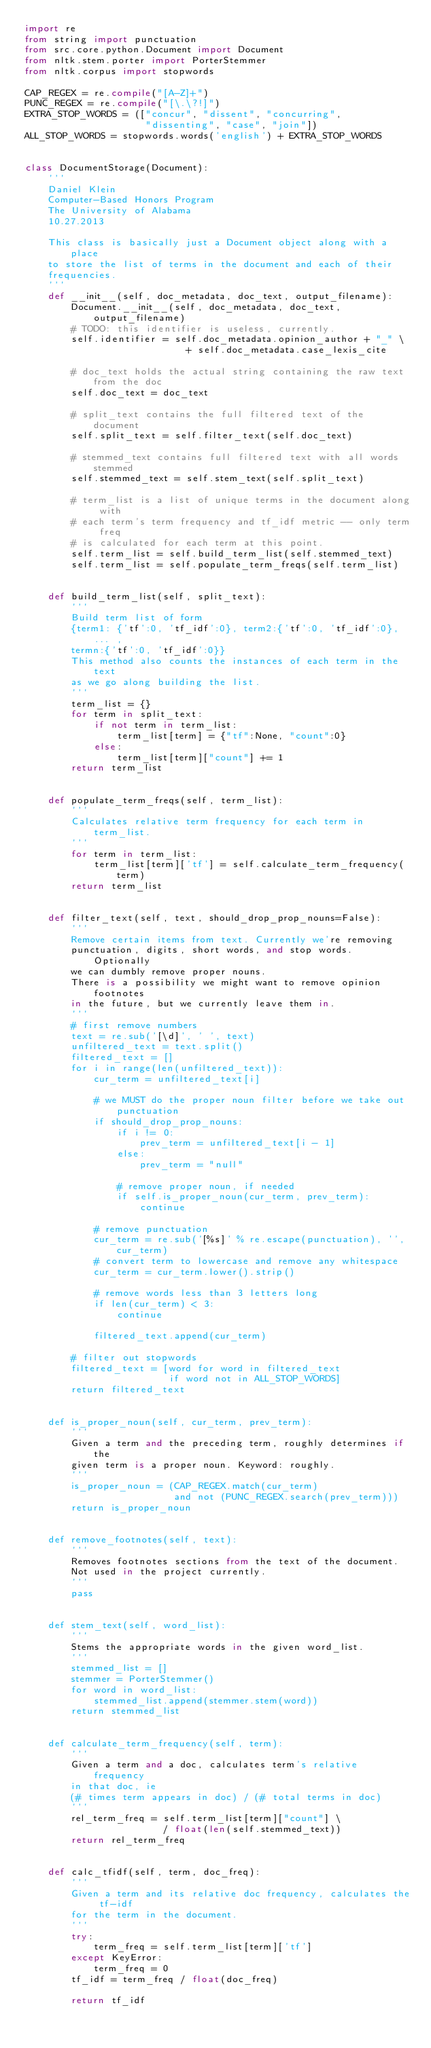<code> <loc_0><loc_0><loc_500><loc_500><_Python_>import re
from string import punctuation
from src.core.python.Document import Document
from nltk.stem.porter import PorterStemmer
from nltk.corpus import stopwords

CAP_REGEX = re.compile("[A-Z]+")
PUNC_REGEX = re.compile("[\.\?!]")
EXTRA_STOP_WORDS = (["concur", "dissent", "concurring", 
                     "dissenting", "case", "join"])
ALL_STOP_WORDS = stopwords.words('english') + EXTRA_STOP_WORDS


class DocumentStorage(Document):
    '''
    Daniel Klein
    Computer-Based Honors Program
    The University of Alabama
    10.27.2013
    
    This class is basically just a Document object along with a place
    to store the list of terms in the document and each of their 
    frequencies.
    '''
    def __init__(self, doc_metadata, doc_text, output_filename):        
        Document.__init__(self, doc_metadata, doc_text, output_filename)
        # TODO: this identifier is useless, currently.
        self.identifier = self.doc_metadata.opinion_author + "_" \
                            + self.doc_metadata.case_lexis_cite
                            
        # doc_text holds the actual string containing the raw text from the doc
        self.doc_text = doc_text

        # split_text contains the full filtered text of the document
        self.split_text = self.filter_text(self.doc_text)
        
        # stemmed_text contains full filtered text with all words stemmed
        self.stemmed_text = self.stem_text(self.split_text)
        
        # term_list is a list of unique terms in the document along with
        # each term's term frequency and tf_idf metric -- only term freq
        # is calculated for each term at this point.
        self.term_list = self.build_term_list(self.stemmed_text)
        self.term_list = self.populate_term_freqs(self.term_list)
        
        
    def build_term_list(self, split_text):
        '''
        Build term list of form 
        {term1: {'tf':0, 'tf_idf':0}, term2:{'tf':0, 'tf_idf':0}, ... , 
        termn:{'tf':0, 'tf_idf':0}}
        This method also counts the instances of each term in the text
        as we go along building the list.
        '''
        term_list = {}
        for term in split_text:
            if not term in term_list:
                term_list[term] = {"tf":None, "count":0}
            else:
                term_list[term]["count"] += 1            
        return term_list
    
    
    def populate_term_freqs(self, term_list):
        '''
        Calculates relative term frequency for each term in term_list.
        '''
        for term in term_list:
            term_list[term]['tf'] = self.calculate_term_frequency(term)
        return term_list
    
    
    def filter_text(self, text, should_drop_prop_nouns=False):
        '''
        Remove certain items from text. Currently we're removing
        punctuation, digits, short words, and stop words. Optionally 
        we can dumbly remove proper nouns. 
        There is a possibility we might want to remove opinion footnotes
        in the future, but we currently leave them in.
        '''
        # first remove numbers
        text = re.sub('[\d]', ' ', text)
        unfiltered_text = text.split()
        filtered_text = []
        for i in range(len(unfiltered_text)):
            cur_term = unfiltered_text[i]   
            
            # we MUST do the proper noun filter before we take out punctuation
            if should_drop_prop_nouns:
                if i != 0:
                    prev_term = unfiltered_text[i - 1]
                else:
                    prev_term = "null"

                # remove proper noun, if needed
                if self.is_proper_noun(cur_term, prev_term):
                    continue
            
            # remove punctuation
            cur_term = re.sub('[%s]' % re.escape(punctuation), '', cur_term)
            # convert term to lowercase and remove any whitespace  
            cur_term = cur_term.lower().strip()
            
            # remove words less than 3 letters long
            if len(cur_term) < 3:
                continue
          
            filtered_text.append(cur_term)
            
        # filter out stopwords
        filtered_text = [word for word in filtered_text 
                         if word not in ALL_STOP_WORDS] 
        return filtered_text
        
        
    def is_proper_noun(self, cur_term, prev_term):
        '''
        Given a term and the preceding term, roughly determines if the 
        given term is a proper noun. Keyword: roughly.
        '''
        is_proper_noun = (CAP_REGEX.match(cur_term)
                          and not (PUNC_REGEX.search(prev_term)))
        return is_proper_noun
        
    
    def remove_footnotes(self, text):
        '''
        Removes footnotes sections from the text of the document.
        Not used in the project currently.
        '''
        pass
    
    
    def stem_text(self, word_list):
        '''
        Stems the appropriate words in the given word_list.
        '''
        stemmed_list = []
        stemmer = PorterStemmer()
        for word in word_list:
            stemmed_list.append(stemmer.stem(word))
        return stemmed_list
    
    
    def calculate_term_frequency(self, term):
        '''
        Given a term and a doc, calculates term's relative frequency
        in that doc, ie
        (# times term appears in doc) / (# total terms in doc)
        '''
        rel_term_freq = self.term_list[term]["count"] \
                        / float(len(self.stemmed_text))
        return rel_term_freq
    
    
    def calc_tfidf(self, term, doc_freq):
        '''
        Given a term and its relative doc frequency, calculates the tf-idf 
        for the term in the document.
        '''
        try:
            term_freq = self.term_list[term]['tf']
        except KeyError:
            term_freq = 0
        tf_idf = term_freq / float(doc_freq)

        return tf_idf

        </code> 